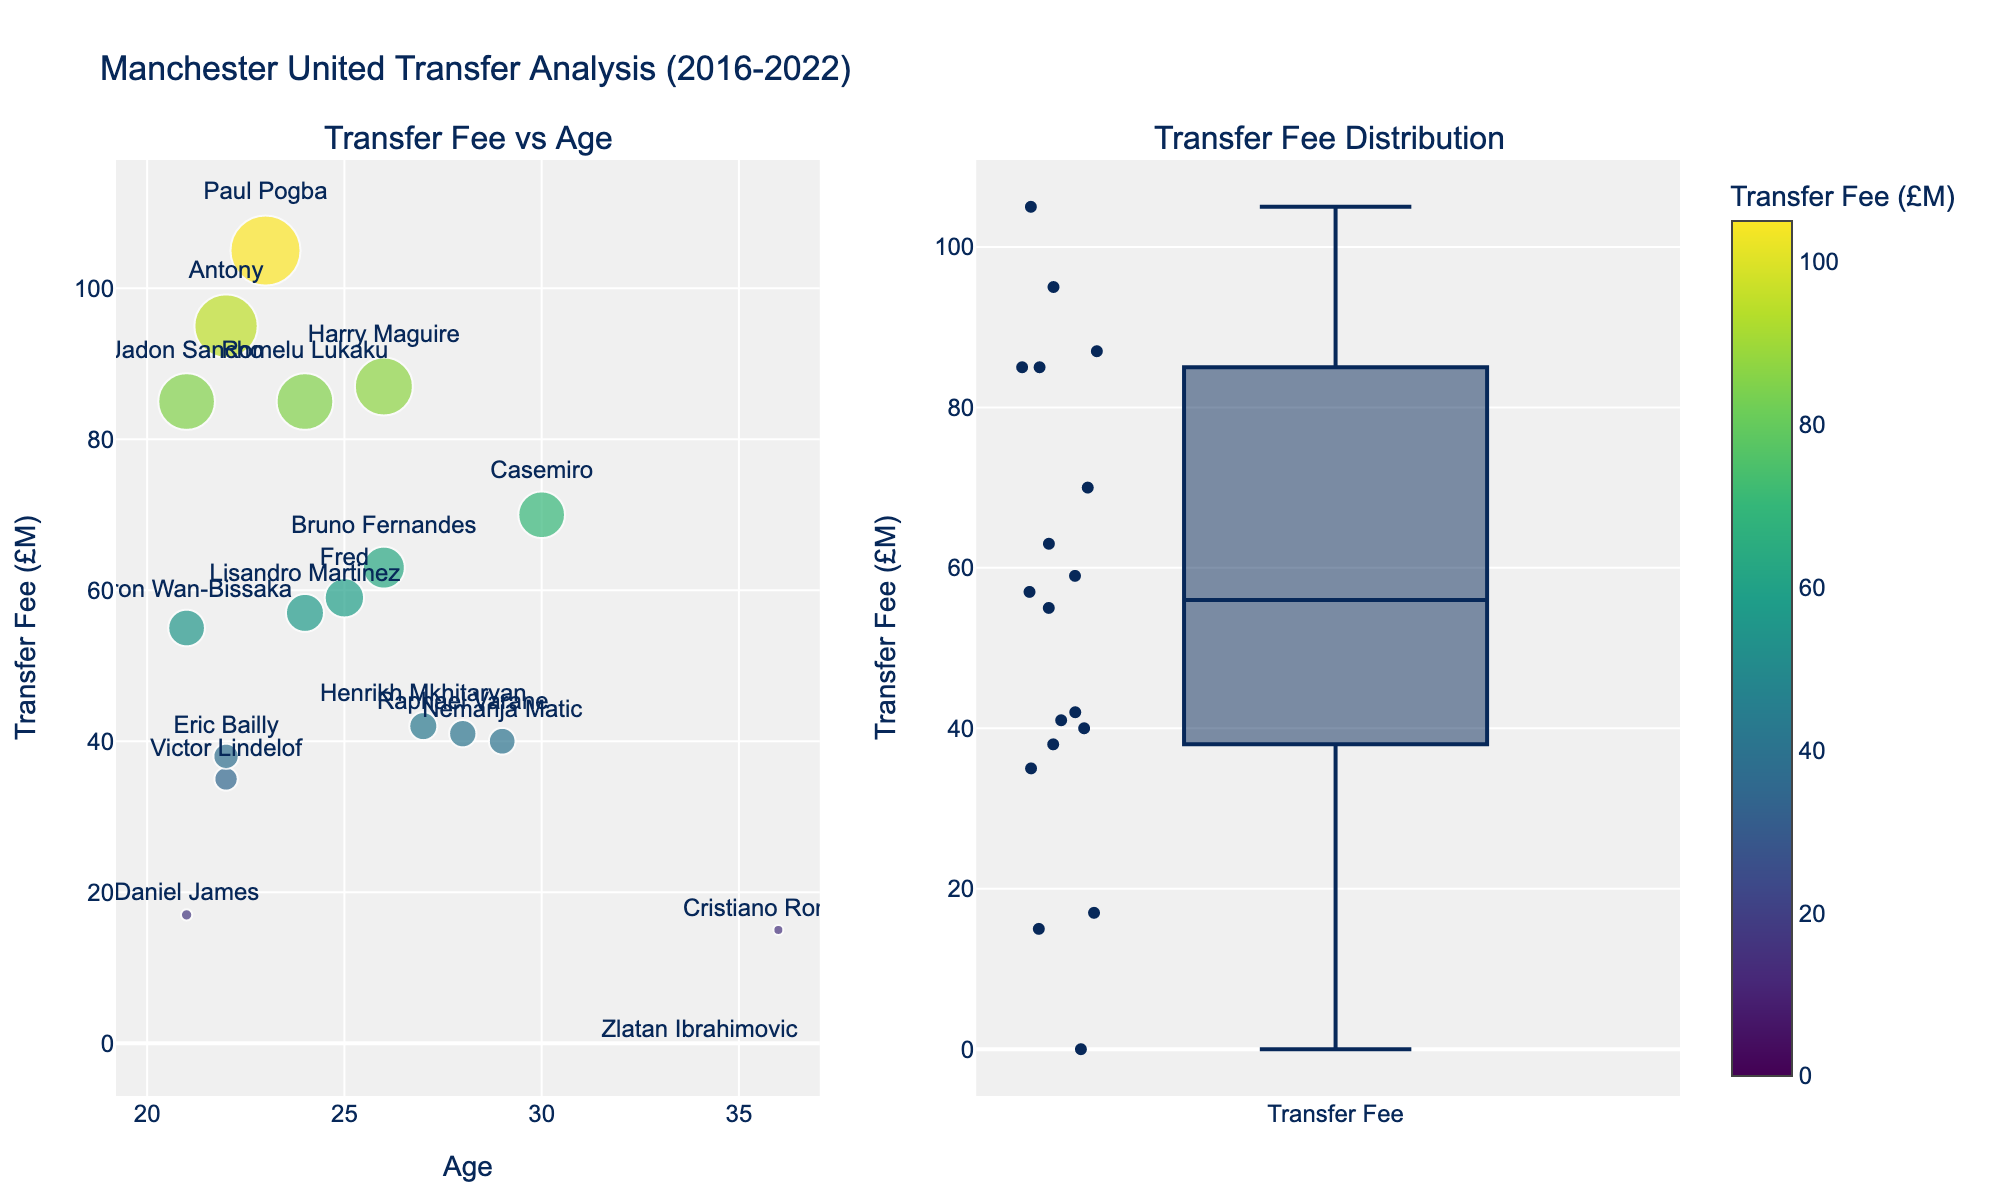What are the dimensions displayed in this scatterplot matrix? The scatterplot matrix shows three dimensions: Batting Average, Home Runs, and Fielding Percentage. You can identify these from the axis labels.
Answer: Batting Average, Home Runs, Fielding Percentage Which league has the highest Fielding Percentage among the players? To find the highest Fielding Percentage, look at the top-right diagonal in the cells involving Fielding Percentage. The highest point is around 0.993, and it belongs to a player from the Muscatine City League.
Answer: Muscatine City League Who has the highest number of Home Runs, and which league are they from? Look at the scatterpoints along the Home Runs axis. The highest value, 22, belongs to Chris Taylor, indicated by the color unique to the Iowa Valley League.
Answer: Chris Taylor from Iowa Valley League How do the Batting Averages of players from the Iowa Valley League compare to those from the Mississippi Valley League? Compare the scatter points for Batting Average. Players from the Iowa Valley League generally have higher Batting Averages (ranging from around 0.321 to 0.337), while those from the Mississippi Valley League have averages ranging from roughly 0.295 to 0.302.
Answer: Iowa Valley League players have higher Batting Averages Which player has both a high Batting Average and a high number of Home Runs? Check the scatterpoint for Batting Average and Home Runs combined. Chris Taylor stands out with a high Batting Average of 0.337 and 22 Home Runs.
Answer: Chris Taylor Is there any correlation between Home Runs and Fielding Percentage? Look at the scatter points in the cell where Home Runs and Fielding Percentage intersect. There is no clear pattern suggesting correlation; the points are spread out.
Answer: No clear correlation Which league has the widest range of Batting Averages among its players? Observe the spread of points along the Batting Average axis for each league. The Iowa Valley League has the widest range, from 0.321 to 0.337.
Answer: Iowa Valley League How does the Fielding Percentage of players from the Muscatine City League compare to those from the Eastern Iowa Hawkeye League? Compare the scatter points for Fielding Percentage between the two leagues. Muscatine City League players have slightly higher Fielding Percentages around 0.990 to 0.993, while Eastern Iowa Hawkeye League players range from about 0.977 to 0.982.
Answer: Muscatine City League players have higher Fielding Percentages Are there any players with a low Batting Average but a high number of Home Runs? Check for points on the lower end of the Batting Average axis but higher on the Home Runs axis. Mike Johnson stands out with a Batting Average of 0.302 and 18 Home Runs.
Answer: Mike Johnson Which player from the Eastern Iowa Hawkeye League has the highest Batting Average, and what is that value? Focus on the points for Batting Average related to Eastern Iowa Hawkeye League. The highest value is 0.315, which belongs to Tom Wilson.
Answer: Tom Wilson with 0.315 